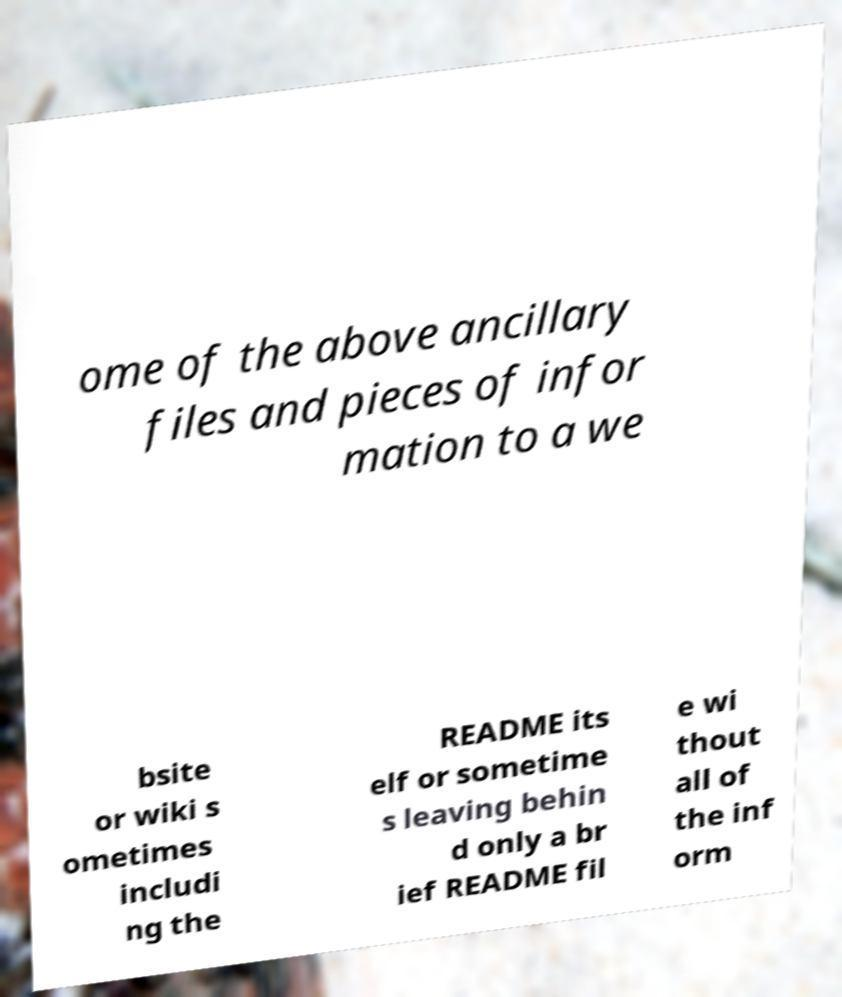Please identify and transcribe the text found in this image. ome of the above ancillary files and pieces of infor mation to a we bsite or wiki s ometimes includi ng the README its elf or sometime s leaving behin d only a br ief README fil e wi thout all of the inf orm 